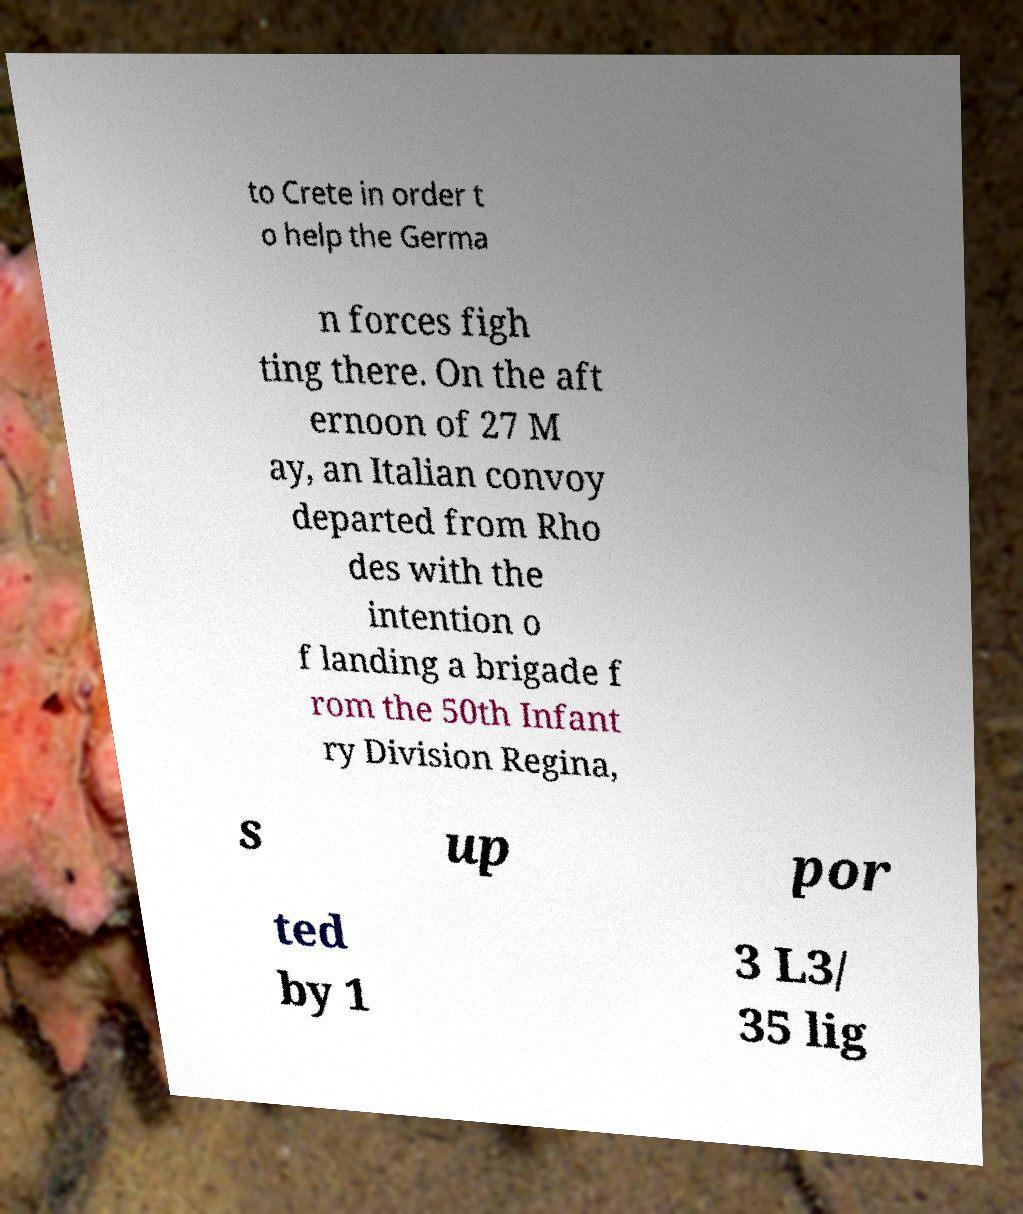Can you accurately transcribe the text from the provided image for me? to Crete in order t o help the Germa n forces figh ting there. On the aft ernoon of 27 M ay, an Italian convoy departed from Rho des with the intention o f landing a brigade f rom the 50th Infant ry Division Regina, s up por ted by 1 3 L3/ 35 lig 